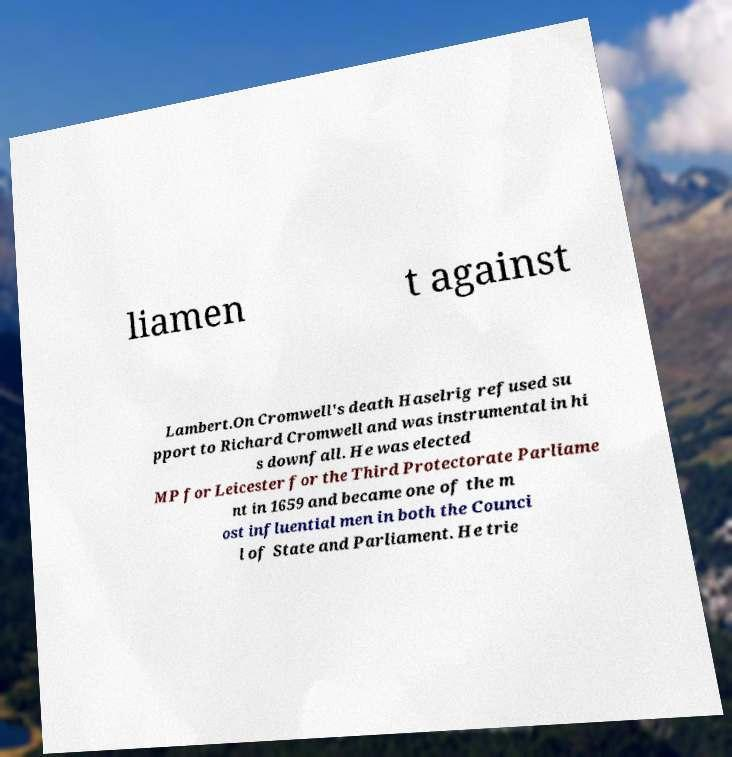What messages or text are displayed in this image? I need them in a readable, typed format. liamen t against Lambert.On Cromwell's death Haselrig refused su pport to Richard Cromwell and was instrumental in hi s downfall. He was elected MP for Leicester for the Third Protectorate Parliame nt in 1659 and became one of the m ost influential men in both the Counci l of State and Parliament. He trie 